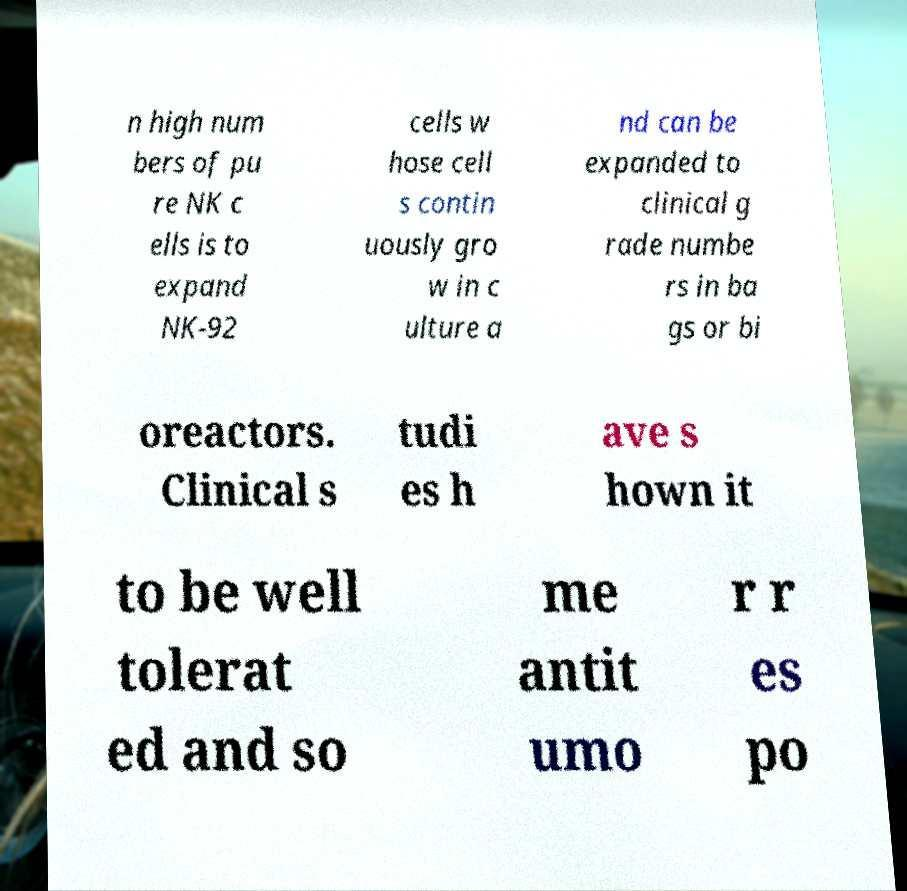Can you read and provide the text displayed in the image?This photo seems to have some interesting text. Can you extract and type it out for me? n high num bers of pu re NK c ells is to expand NK-92 cells w hose cell s contin uously gro w in c ulture a nd can be expanded to clinical g rade numbe rs in ba gs or bi oreactors. Clinical s tudi es h ave s hown it to be well tolerat ed and so me antit umo r r es po 